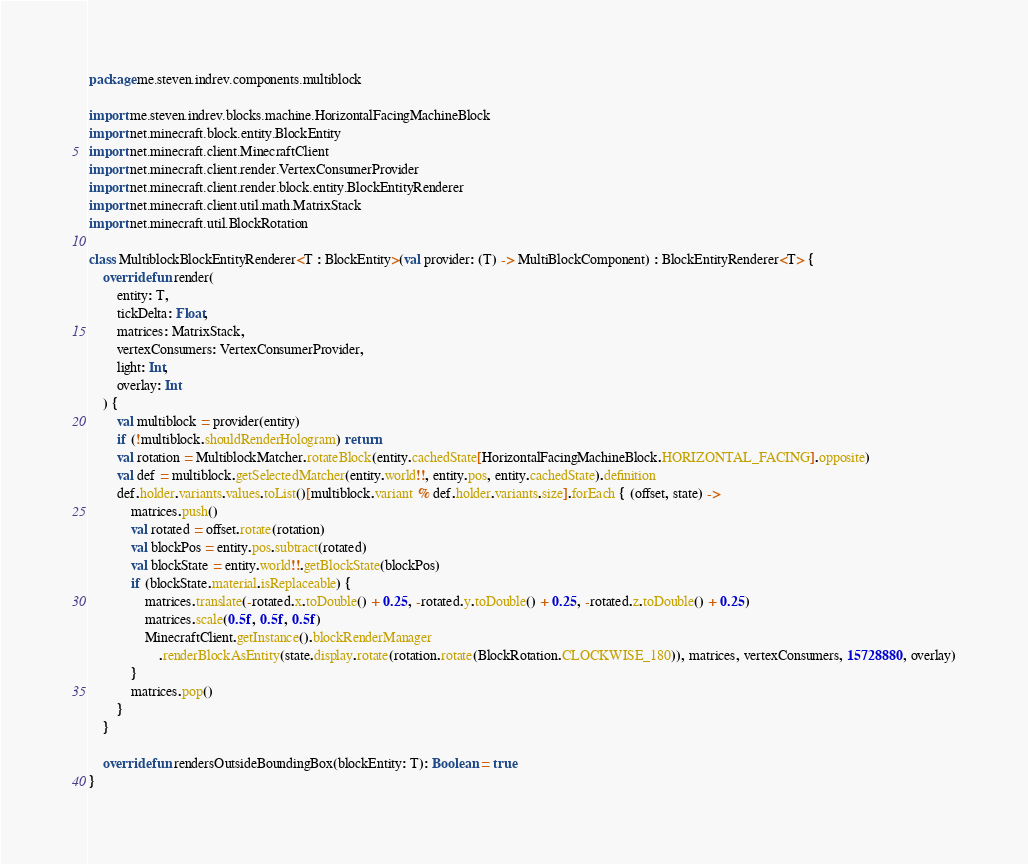<code> <loc_0><loc_0><loc_500><loc_500><_Kotlin_>package me.steven.indrev.components.multiblock

import me.steven.indrev.blocks.machine.HorizontalFacingMachineBlock
import net.minecraft.block.entity.BlockEntity
import net.minecraft.client.MinecraftClient
import net.minecraft.client.render.VertexConsumerProvider
import net.minecraft.client.render.block.entity.BlockEntityRenderer
import net.minecraft.client.util.math.MatrixStack
import net.minecraft.util.BlockRotation

class MultiblockBlockEntityRenderer<T : BlockEntity>(val provider: (T) -> MultiBlockComponent) : BlockEntityRenderer<T> {
    override fun render(
        entity: T,
        tickDelta: Float,
        matrices: MatrixStack,
        vertexConsumers: VertexConsumerProvider,
        light: Int,
        overlay: Int
    ) {
        val multiblock = provider(entity)
        if (!multiblock.shouldRenderHologram) return
        val rotation = MultiblockMatcher.rotateBlock(entity.cachedState[HorizontalFacingMachineBlock.HORIZONTAL_FACING].opposite)
        val def = multiblock.getSelectedMatcher(entity.world!!, entity.pos, entity.cachedState).definition
        def.holder.variants.values.toList()[multiblock.variant % def.holder.variants.size].forEach { (offset, state) ->
            matrices.push()
            val rotated = offset.rotate(rotation)
            val blockPos = entity.pos.subtract(rotated)
            val blockState = entity.world!!.getBlockState(blockPos)
            if (blockState.material.isReplaceable) {
                matrices.translate(-rotated.x.toDouble() + 0.25, -rotated.y.toDouble() + 0.25, -rotated.z.toDouble() + 0.25)
                matrices.scale(0.5f, 0.5f, 0.5f)
                MinecraftClient.getInstance().blockRenderManager
                    .renderBlockAsEntity(state.display.rotate(rotation.rotate(BlockRotation.CLOCKWISE_180)), matrices, vertexConsumers, 15728880, overlay)
            }
            matrices.pop()
        }
    }

    override fun rendersOutsideBoundingBox(blockEntity: T): Boolean = true
}</code> 